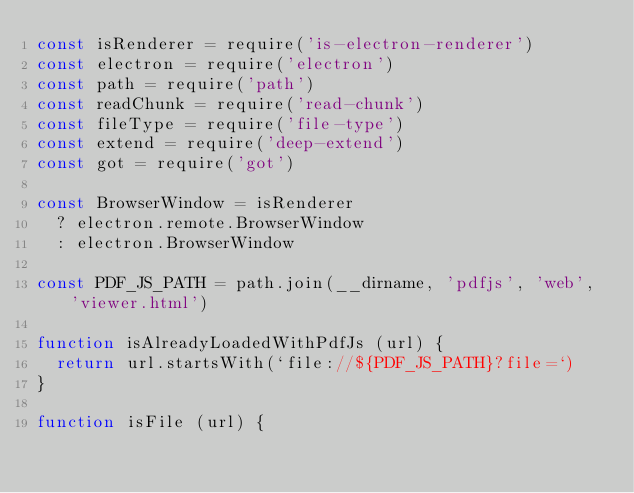<code> <loc_0><loc_0><loc_500><loc_500><_JavaScript_>const isRenderer = require('is-electron-renderer')
const electron = require('electron')
const path = require('path')
const readChunk = require('read-chunk')
const fileType = require('file-type')
const extend = require('deep-extend')
const got = require('got')

const BrowserWindow = isRenderer
  ? electron.remote.BrowserWindow
  : electron.BrowserWindow

const PDF_JS_PATH = path.join(__dirname, 'pdfjs', 'web', 'viewer.html')

function isAlreadyLoadedWithPdfJs (url) {
  return url.startsWith(`file://${PDF_JS_PATH}?file=`)
}

function isFile (url) {</code> 